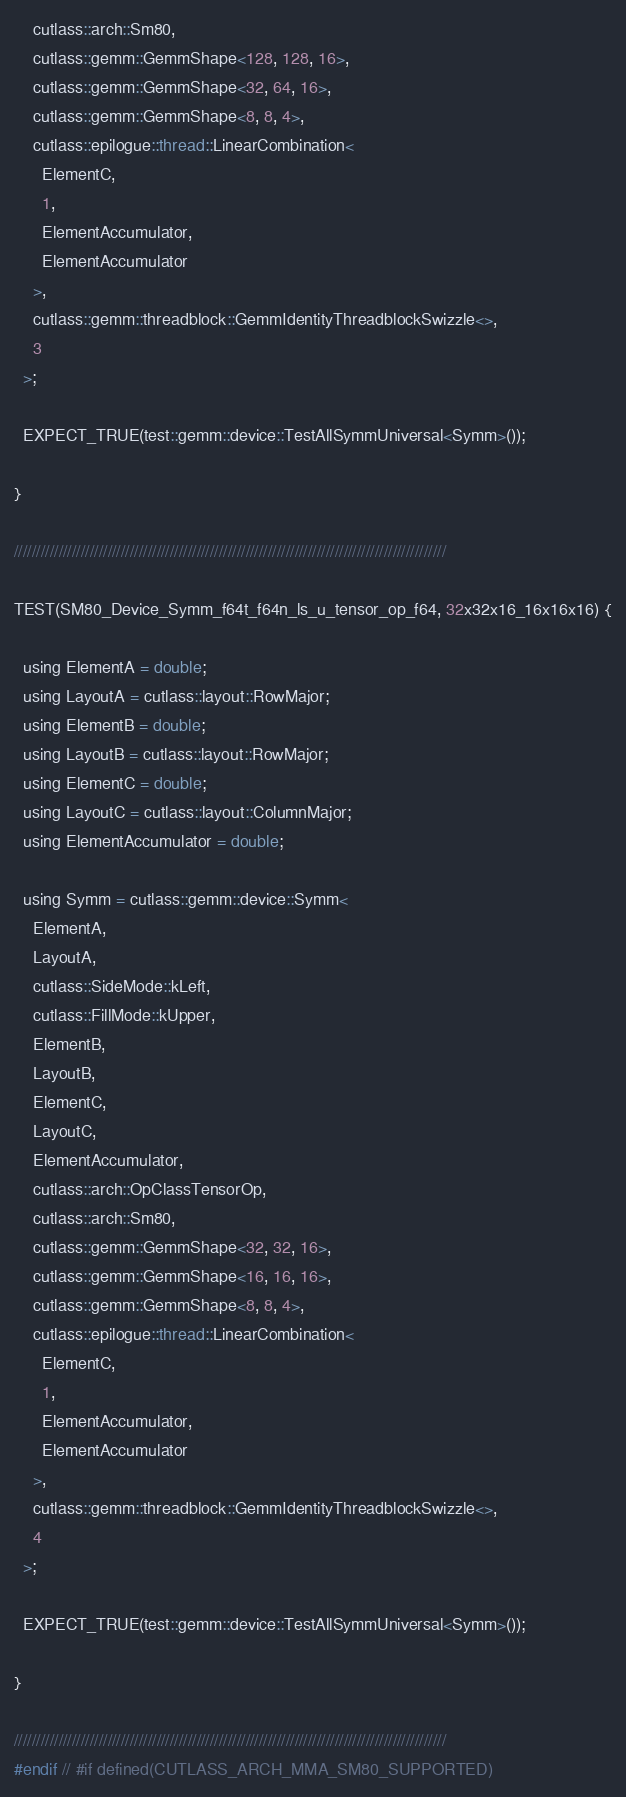<code> <loc_0><loc_0><loc_500><loc_500><_Cuda_>    cutlass::arch::Sm80,
    cutlass::gemm::GemmShape<128, 128, 16>,
    cutlass::gemm::GemmShape<32, 64, 16>,
    cutlass::gemm::GemmShape<8, 8, 4>,
    cutlass::epilogue::thread::LinearCombination<
      ElementC,
      1,
      ElementAccumulator,
      ElementAccumulator
    >,
    cutlass::gemm::threadblock::GemmIdentityThreadblockSwizzle<>,
    3
  >;

  EXPECT_TRUE(test::gemm::device::TestAllSymmUniversal<Symm>());

}

/////////////////////////////////////////////////////////////////////////////////////////////////

TEST(SM80_Device_Symm_f64t_f64n_ls_u_tensor_op_f64, 32x32x16_16x16x16) {

  using ElementA = double;
  using LayoutA = cutlass::layout::RowMajor;
  using ElementB = double;
  using LayoutB = cutlass::layout::RowMajor;
  using ElementC = double;
  using LayoutC = cutlass::layout::ColumnMajor;
  using ElementAccumulator = double;

  using Symm = cutlass::gemm::device::Symm<
    ElementA,
    LayoutA,
    cutlass::SideMode::kLeft,
    cutlass::FillMode::kUpper,
    ElementB,
    LayoutB,
    ElementC,
    LayoutC,
    ElementAccumulator,
    cutlass::arch::OpClassTensorOp,
    cutlass::arch::Sm80,
    cutlass::gemm::GemmShape<32, 32, 16>,
    cutlass::gemm::GemmShape<16, 16, 16>,
    cutlass::gemm::GemmShape<8, 8, 4>,
    cutlass::epilogue::thread::LinearCombination<
      ElementC,
      1,
      ElementAccumulator,
      ElementAccumulator
    >,
    cutlass::gemm::threadblock::GemmIdentityThreadblockSwizzle<>,
    4
  >;

  EXPECT_TRUE(test::gemm::device::TestAllSymmUniversal<Symm>());

}

/////////////////////////////////////////////////////////////////////////////////////////////////
#endif // #if defined(CUTLASS_ARCH_MMA_SM80_SUPPORTED)
</code> 